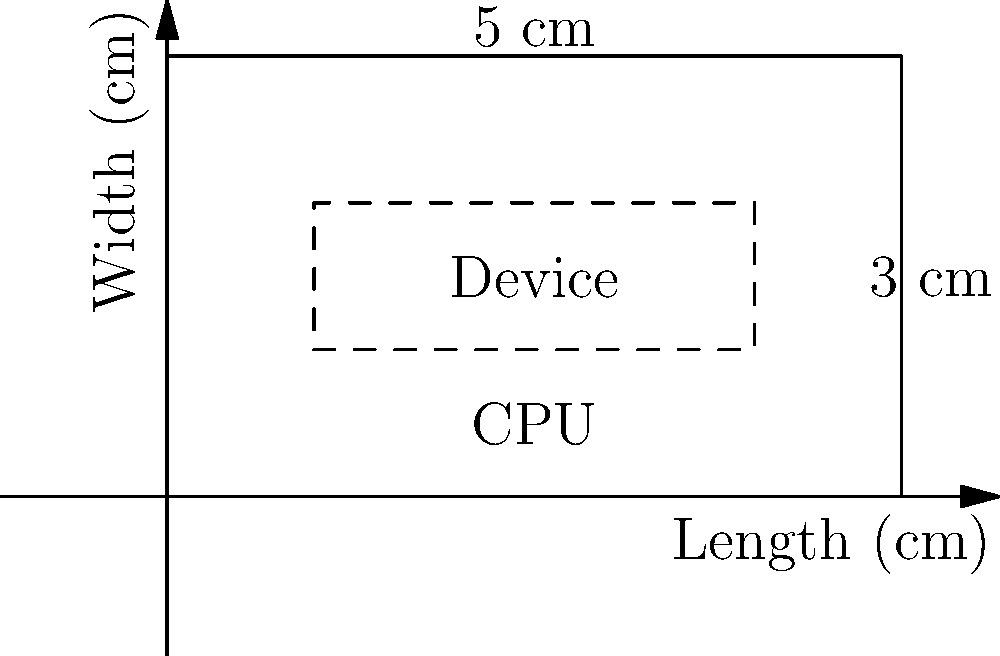A new compact electronic device measures 5 cm x 3 cm x 1 cm. The device contains a CPU that generates 2.5 W of heat. The device's casing has a thermal conductivity of 15 W/(m·K). If the internal temperature is 70°C and the ambient temperature is 25°C, calculate the heat dissipation rate in watts. Assume the heat is primarily dissipated through the largest surface area (5 cm x 3 cm). To calculate the heat dissipation rate, we'll use Fourier's Law of Heat Conduction:

$$ Q = k \cdot A \cdot \frac{\Delta T}{d} $$

Where:
- $Q$ = Heat dissipation rate (W)
- $k$ = Thermal conductivity of the casing (W/(m·K))
- $A$ = Surface area (m²)
- $\Delta T$ = Temperature difference (K)
- $d$ = Thickness of the casing (m)

Step 1: Convert dimensions to meters
- Surface area: $A = 0.05 \text{ m} \times 0.03 \text{ m} = 0.0015 \text{ m}^2$
- Thickness: $d = 0.01 \text{ m}$

Step 2: Calculate temperature difference
$\Delta T = 70°\text{C} - 25°\text{C} = 45 \text{ K}$

Step 3: Apply Fourier's Law
$$ Q = 15 \frac{\text{W}}{\text{m}\cdot\text{K}} \cdot 0.0015 \text{ m}^2 \cdot \frac{45 \text{ K}}{0.01 \text{ m}} $$

Step 4: Calculate the result
$$ Q = 101.25 \text{ W} $$

The heat dissipation rate is 101.25 W, which is significantly higher than the heat generated by the CPU (2.5 W). This indicates that the device's cooling system is more than capable of handling the heat produced by the CPU.
Answer: 101.25 W 